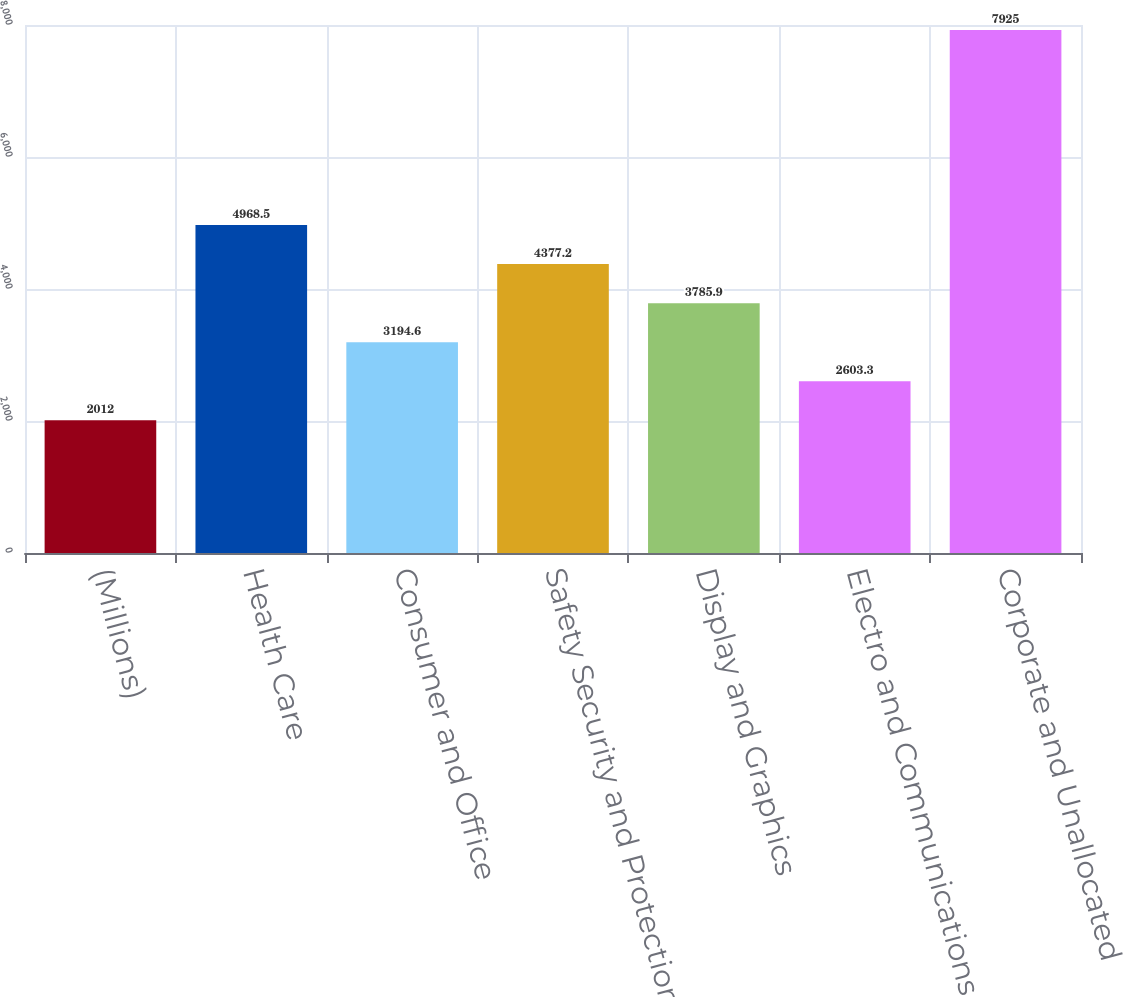Convert chart. <chart><loc_0><loc_0><loc_500><loc_500><bar_chart><fcel>(Millions)<fcel>Health Care<fcel>Consumer and Office<fcel>Safety Security and Protection<fcel>Display and Graphics<fcel>Electro and Communications<fcel>Corporate and Unallocated<nl><fcel>2012<fcel>4968.5<fcel>3194.6<fcel>4377.2<fcel>3785.9<fcel>2603.3<fcel>7925<nl></chart> 